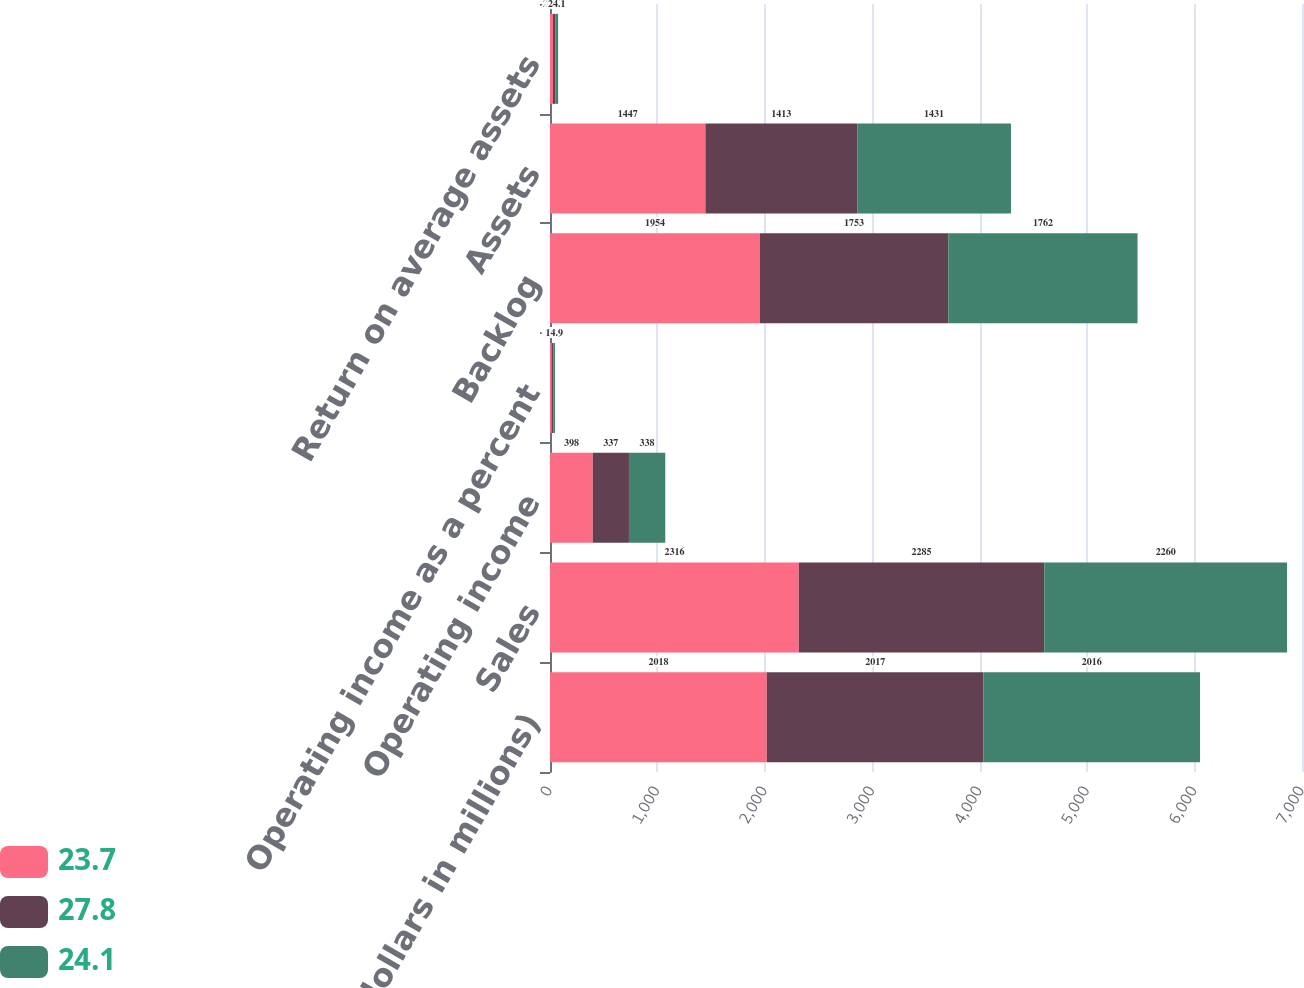<chart> <loc_0><loc_0><loc_500><loc_500><stacked_bar_chart><ecel><fcel>(dollars in millions)<fcel>Sales<fcel>Operating income<fcel>Operating income as a percent<fcel>Backlog<fcel>Assets<fcel>Return on average assets<nl><fcel>23.7<fcel>2018<fcel>2316<fcel>398<fcel>17.2<fcel>1954<fcel>1447<fcel>27.8<nl><fcel>27.8<fcel>2017<fcel>2285<fcel>337<fcel>14.8<fcel>1753<fcel>1413<fcel>23.7<nl><fcel>24.1<fcel>2016<fcel>2260<fcel>338<fcel>14.9<fcel>1762<fcel>1431<fcel>24.1<nl></chart> 